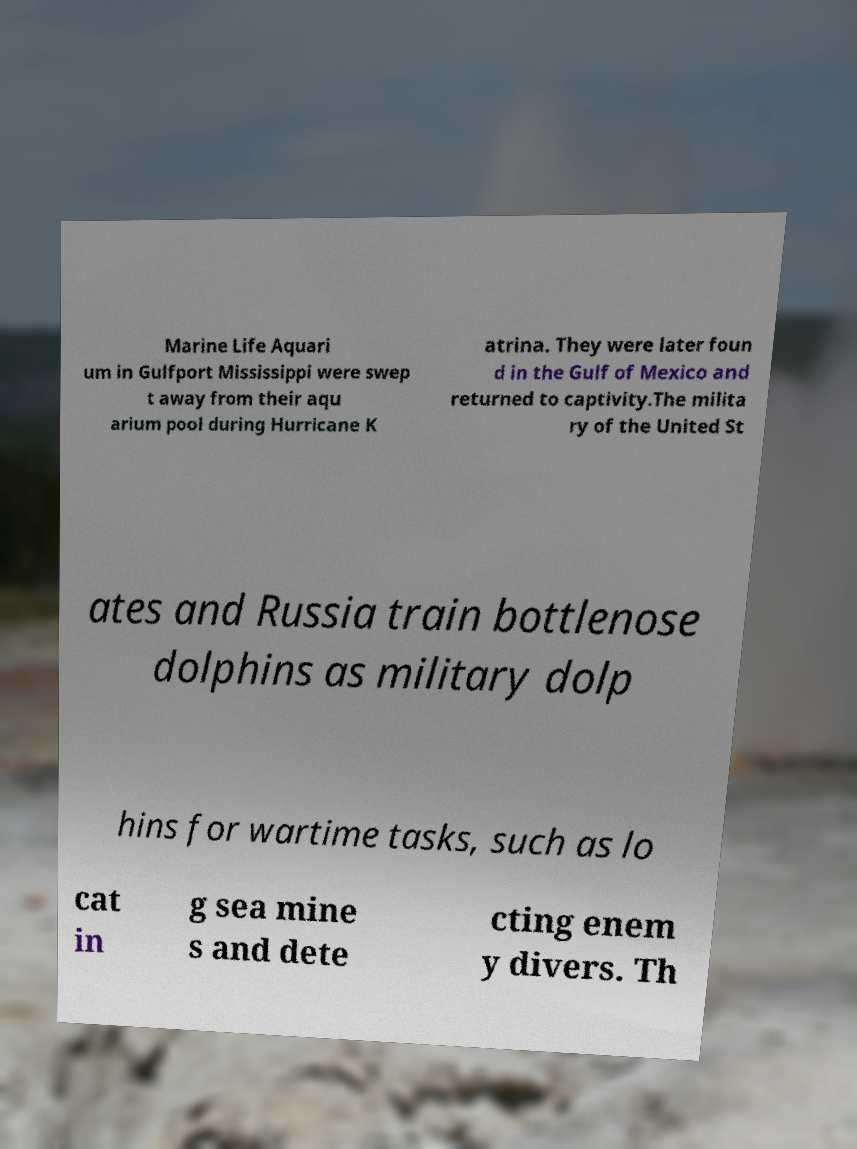Please read and relay the text visible in this image. What does it say? Marine Life Aquari um in Gulfport Mississippi were swep t away from their aqu arium pool during Hurricane K atrina. They were later foun d in the Gulf of Mexico and returned to captivity.The milita ry of the United St ates and Russia train bottlenose dolphins as military dolp hins for wartime tasks, such as lo cat in g sea mine s and dete cting enem y divers. Th 